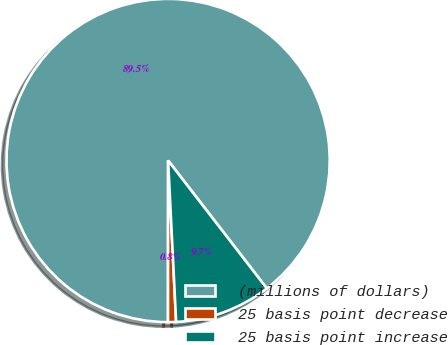Convert chart to OTSL. <chart><loc_0><loc_0><loc_500><loc_500><pie_chart><fcel>(millions of dollars)<fcel>25 basis point decrease<fcel>25 basis point increase<nl><fcel>89.53%<fcel>0.8%<fcel>9.67%<nl></chart> 